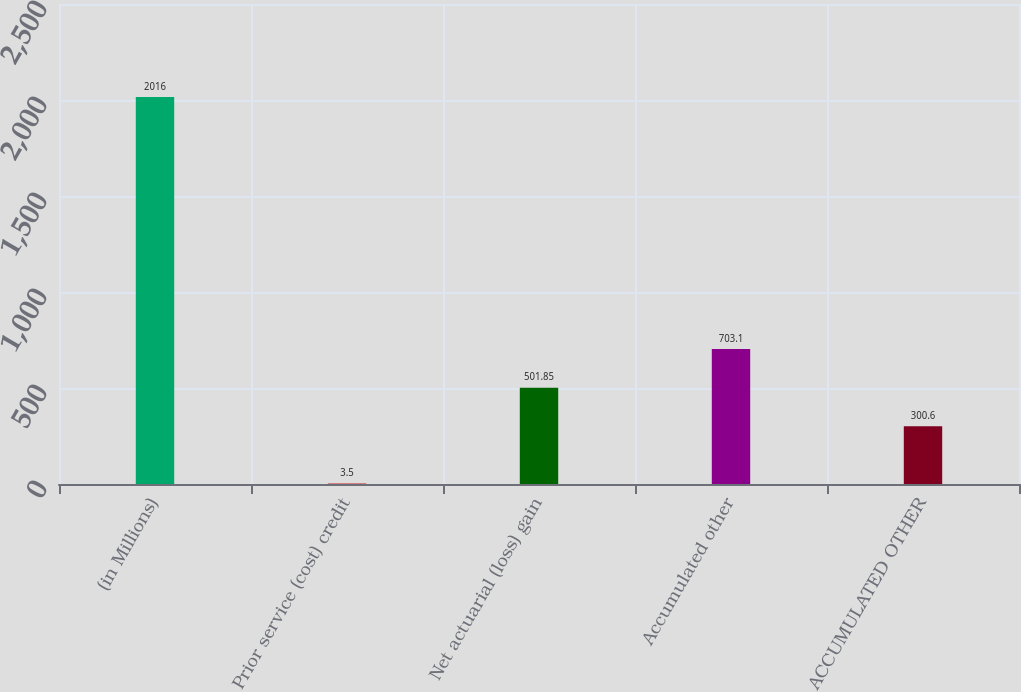Convert chart. <chart><loc_0><loc_0><loc_500><loc_500><bar_chart><fcel>(in Millions)<fcel>Prior service (cost) credit<fcel>Net actuarial (loss) gain<fcel>Accumulated other<fcel>ACCUMULATED OTHER<nl><fcel>2016<fcel>3.5<fcel>501.85<fcel>703.1<fcel>300.6<nl></chart> 